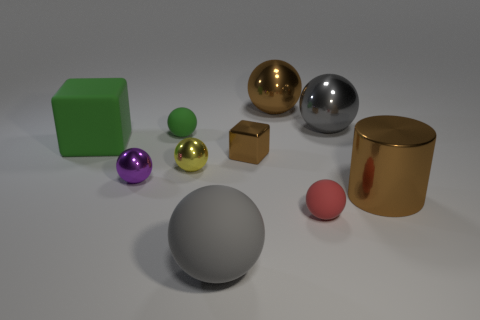There is a large gray thing that is in front of the tiny brown shiny thing; how many big metallic things are on the right side of it?
Ensure brevity in your answer.  3. Are there any big green rubber things in front of the tiny purple thing?
Ensure brevity in your answer.  No. There is a big thing that is left of the tiny yellow shiny sphere that is behind the purple ball; what shape is it?
Your response must be concise. Cube. Are there fewer yellow things that are behind the tiny green matte object than green blocks that are behind the tiny red matte ball?
Your response must be concise. Yes. What color is the large rubber thing that is the same shape as the small purple shiny object?
Offer a very short reply. Gray. How many objects are both left of the large brown cylinder and in front of the small purple shiny thing?
Your answer should be compact. 2. Is the number of small yellow metallic objects that are in front of the brown metal cube greater than the number of tiny things right of the red matte thing?
Make the answer very short. Yes. The cylinder has what size?
Offer a terse response. Large. Is there a large blue rubber object that has the same shape as the tiny purple object?
Your response must be concise. No. Is the shape of the small purple object the same as the large brown thing on the right side of the tiny red thing?
Make the answer very short. No. 